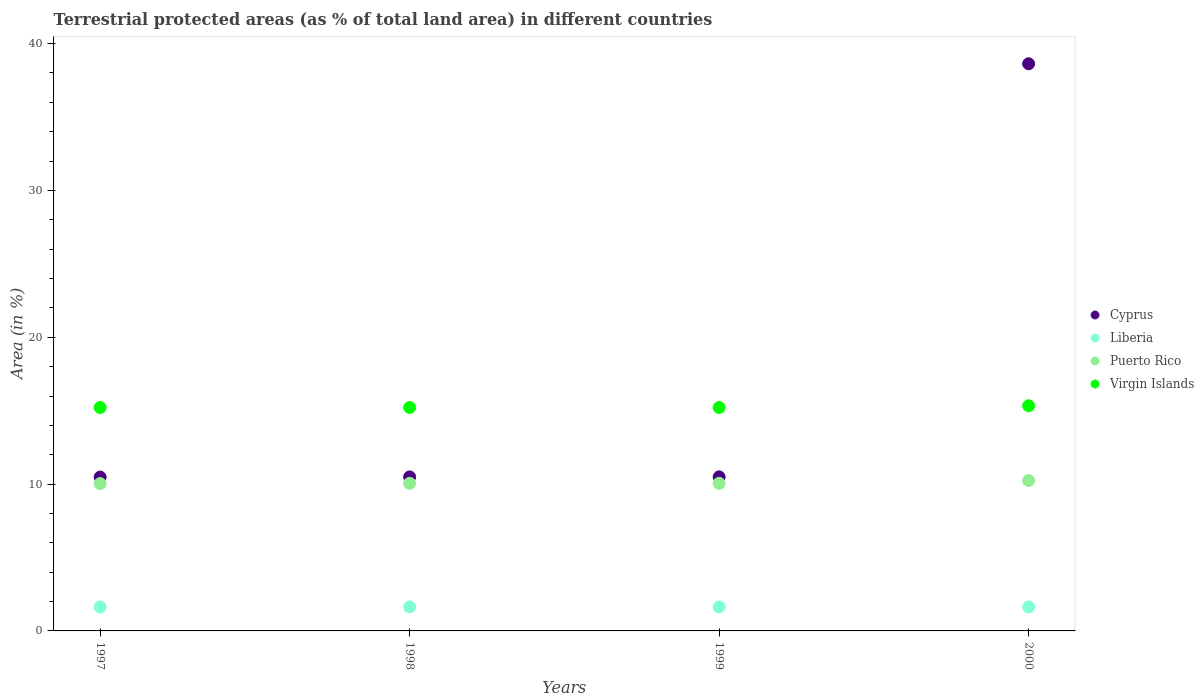What is the percentage of terrestrial protected land in Virgin Islands in 1999?
Ensure brevity in your answer.  15.22. Across all years, what is the maximum percentage of terrestrial protected land in Virgin Islands?
Make the answer very short. 15.34. Across all years, what is the minimum percentage of terrestrial protected land in Puerto Rico?
Your answer should be compact. 10.04. In which year was the percentage of terrestrial protected land in Cyprus maximum?
Keep it short and to the point. 2000. In which year was the percentage of terrestrial protected land in Cyprus minimum?
Provide a short and direct response. 1997. What is the total percentage of terrestrial protected land in Cyprus in the graph?
Provide a succinct answer. 70.09. What is the difference between the percentage of terrestrial protected land in Virgin Islands in 1998 and that in 2000?
Give a very brief answer. -0.12. What is the difference between the percentage of terrestrial protected land in Puerto Rico in 1998 and the percentage of terrestrial protected land in Virgin Islands in 1999?
Keep it short and to the point. -5.16. What is the average percentage of terrestrial protected land in Cyprus per year?
Your answer should be compact. 17.52. In the year 1998, what is the difference between the percentage of terrestrial protected land in Virgin Islands and percentage of terrestrial protected land in Puerto Rico?
Your answer should be compact. 5.16. What is the ratio of the percentage of terrestrial protected land in Virgin Islands in 1997 to that in 2000?
Ensure brevity in your answer.  0.99. What is the difference between the highest and the second highest percentage of terrestrial protected land in Cyprus?
Offer a very short reply. 28.14. What is the difference between the highest and the lowest percentage of terrestrial protected land in Cyprus?
Your answer should be very brief. 28.15. In how many years, is the percentage of terrestrial protected land in Puerto Rico greater than the average percentage of terrestrial protected land in Puerto Rico taken over all years?
Your answer should be compact. 1. Is the sum of the percentage of terrestrial protected land in Puerto Rico in 1998 and 1999 greater than the maximum percentage of terrestrial protected land in Liberia across all years?
Your response must be concise. Yes. Does the percentage of terrestrial protected land in Puerto Rico monotonically increase over the years?
Offer a terse response. No. Is the percentage of terrestrial protected land in Virgin Islands strictly less than the percentage of terrestrial protected land in Liberia over the years?
Make the answer very short. No. How many dotlines are there?
Provide a short and direct response. 4. Does the graph contain grids?
Offer a very short reply. No. How are the legend labels stacked?
Your answer should be compact. Vertical. What is the title of the graph?
Keep it short and to the point. Terrestrial protected areas (as % of total land area) in different countries. Does "Denmark" appear as one of the legend labels in the graph?
Make the answer very short. No. What is the label or title of the Y-axis?
Offer a very short reply. Area (in %). What is the Area (in %) in Cyprus in 1997?
Keep it short and to the point. 10.48. What is the Area (in %) in Liberia in 1997?
Your response must be concise. 1.63. What is the Area (in %) in Puerto Rico in 1997?
Make the answer very short. 10.04. What is the Area (in %) of Virgin Islands in 1997?
Ensure brevity in your answer.  15.22. What is the Area (in %) of Cyprus in 1998?
Ensure brevity in your answer.  10.49. What is the Area (in %) in Liberia in 1998?
Ensure brevity in your answer.  1.63. What is the Area (in %) in Puerto Rico in 1998?
Make the answer very short. 10.05. What is the Area (in %) in Virgin Islands in 1998?
Make the answer very short. 15.22. What is the Area (in %) in Cyprus in 1999?
Offer a terse response. 10.49. What is the Area (in %) of Liberia in 1999?
Your response must be concise. 1.63. What is the Area (in %) of Puerto Rico in 1999?
Make the answer very short. 10.05. What is the Area (in %) of Virgin Islands in 1999?
Give a very brief answer. 15.22. What is the Area (in %) of Cyprus in 2000?
Offer a very short reply. 38.63. What is the Area (in %) of Liberia in 2000?
Offer a terse response. 1.63. What is the Area (in %) in Puerto Rico in 2000?
Your answer should be very brief. 10.24. What is the Area (in %) of Virgin Islands in 2000?
Offer a terse response. 15.34. Across all years, what is the maximum Area (in %) in Cyprus?
Give a very brief answer. 38.63. Across all years, what is the maximum Area (in %) of Liberia?
Your answer should be compact. 1.63. Across all years, what is the maximum Area (in %) in Puerto Rico?
Make the answer very short. 10.24. Across all years, what is the maximum Area (in %) of Virgin Islands?
Your response must be concise. 15.34. Across all years, what is the minimum Area (in %) of Cyprus?
Make the answer very short. 10.48. Across all years, what is the minimum Area (in %) of Liberia?
Make the answer very short. 1.63. Across all years, what is the minimum Area (in %) of Puerto Rico?
Provide a succinct answer. 10.04. Across all years, what is the minimum Area (in %) of Virgin Islands?
Your answer should be compact. 15.22. What is the total Area (in %) of Cyprus in the graph?
Make the answer very short. 70.09. What is the total Area (in %) of Liberia in the graph?
Ensure brevity in your answer.  6.53. What is the total Area (in %) in Puerto Rico in the graph?
Give a very brief answer. 40.39. What is the total Area (in %) in Virgin Islands in the graph?
Ensure brevity in your answer.  60.99. What is the difference between the Area (in %) of Cyprus in 1997 and that in 1998?
Your response must be concise. -0.01. What is the difference between the Area (in %) in Liberia in 1997 and that in 1998?
Your response must be concise. 0. What is the difference between the Area (in %) of Puerto Rico in 1997 and that in 1998?
Keep it short and to the point. -0.02. What is the difference between the Area (in %) of Cyprus in 1997 and that in 1999?
Provide a succinct answer. -0.01. What is the difference between the Area (in %) in Liberia in 1997 and that in 1999?
Your answer should be very brief. 0. What is the difference between the Area (in %) of Puerto Rico in 1997 and that in 1999?
Give a very brief answer. -0.02. What is the difference between the Area (in %) in Virgin Islands in 1997 and that in 1999?
Offer a terse response. 0. What is the difference between the Area (in %) of Cyprus in 1997 and that in 2000?
Offer a very short reply. -28.15. What is the difference between the Area (in %) in Liberia in 1997 and that in 2000?
Offer a very short reply. 0. What is the difference between the Area (in %) in Puerto Rico in 1997 and that in 2000?
Ensure brevity in your answer.  -0.2. What is the difference between the Area (in %) in Virgin Islands in 1997 and that in 2000?
Your response must be concise. -0.12. What is the difference between the Area (in %) of Cyprus in 1998 and that in 1999?
Provide a short and direct response. -0. What is the difference between the Area (in %) of Puerto Rico in 1998 and that in 1999?
Your answer should be very brief. 0. What is the difference between the Area (in %) of Virgin Islands in 1998 and that in 1999?
Offer a terse response. 0. What is the difference between the Area (in %) in Cyprus in 1998 and that in 2000?
Offer a very short reply. -28.14. What is the difference between the Area (in %) in Liberia in 1998 and that in 2000?
Offer a very short reply. 0. What is the difference between the Area (in %) in Puerto Rico in 1998 and that in 2000?
Offer a very short reply. -0.18. What is the difference between the Area (in %) of Virgin Islands in 1998 and that in 2000?
Your answer should be very brief. -0.12. What is the difference between the Area (in %) of Cyprus in 1999 and that in 2000?
Your response must be concise. -28.14. What is the difference between the Area (in %) of Liberia in 1999 and that in 2000?
Your answer should be compact. 0. What is the difference between the Area (in %) in Puerto Rico in 1999 and that in 2000?
Offer a terse response. -0.18. What is the difference between the Area (in %) in Virgin Islands in 1999 and that in 2000?
Your answer should be very brief. -0.12. What is the difference between the Area (in %) of Cyprus in 1997 and the Area (in %) of Liberia in 1998?
Give a very brief answer. 8.85. What is the difference between the Area (in %) in Cyprus in 1997 and the Area (in %) in Puerto Rico in 1998?
Ensure brevity in your answer.  0.42. What is the difference between the Area (in %) of Cyprus in 1997 and the Area (in %) of Virgin Islands in 1998?
Your answer should be very brief. -4.74. What is the difference between the Area (in %) in Liberia in 1997 and the Area (in %) in Puerto Rico in 1998?
Make the answer very short. -8.42. What is the difference between the Area (in %) of Liberia in 1997 and the Area (in %) of Virgin Islands in 1998?
Make the answer very short. -13.59. What is the difference between the Area (in %) of Puerto Rico in 1997 and the Area (in %) of Virgin Islands in 1998?
Offer a terse response. -5.18. What is the difference between the Area (in %) of Cyprus in 1997 and the Area (in %) of Liberia in 1999?
Offer a very short reply. 8.85. What is the difference between the Area (in %) of Cyprus in 1997 and the Area (in %) of Puerto Rico in 1999?
Ensure brevity in your answer.  0.42. What is the difference between the Area (in %) in Cyprus in 1997 and the Area (in %) in Virgin Islands in 1999?
Your response must be concise. -4.74. What is the difference between the Area (in %) of Liberia in 1997 and the Area (in %) of Puerto Rico in 1999?
Provide a short and direct response. -8.42. What is the difference between the Area (in %) in Liberia in 1997 and the Area (in %) in Virgin Islands in 1999?
Your response must be concise. -13.59. What is the difference between the Area (in %) of Puerto Rico in 1997 and the Area (in %) of Virgin Islands in 1999?
Offer a very short reply. -5.18. What is the difference between the Area (in %) in Cyprus in 1997 and the Area (in %) in Liberia in 2000?
Provide a short and direct response. 8.85. What is the difference between the Area (in %) of Cyprus in 1997 and the Area (in %) of Puerto Rico in 2000?
Keep it short and to the point. 0.24. What is the difference between the Area (in %) in Cyprus in 1997 and the Area (in %) in Virgin Islands in 2000?
Keep it short and to the point. -4.86. What is the difference between the Area (in %) in Liberia in 1997 and the Area (in %) in Puerto Rico in 2000?
Keep it short and to the point. -8.61. What is the difference between the Area (in %) of Liberia in 1997 and the Area (in %) of Virgin Islands in 2000?
Your answer should be very brief. -13.7. What is the difference between the Area (in %) of Puerto Rico in 1997 and the Area (in %) of Virgin Islands in 2000?
Give a very brief answer. -5.3. What is the difference between the Area (in %) in Cyprus in 1998 and the Area (in %) in Liberia in 1999?
Provide a succinct answer. 8.86. What is the difference between the Area (in %) in Cyprus in 1998 and the Area (in %) in Puerto Rico in 1999?
Your answer should be compact. 0.43. What is the difference between the Area (in %) in Cyprus in 1998 and the Area (in %) in Virgin Islands in 1999?
Offer a terse response. -4.73. What is the difference between the Area (in %) of Liberia in 1998 and the Area (in %) of Puerto Rico in 1999?
Your answer should be compact. -8.42. What is the difference between the Area (in %) of Liberia in 1998 and the Area (in %) of Virgin Islands in 1999?
Keep it short and to the point. -13.59. What is the difference between the Area (in %) of Puerto Rico in 1998 and the Area (in %) of Virgin Islands in 1999?
Provide a short and direct response. -5.16. What is the difference between the Area (in %) in Cyprus in 1998 and the Area (in %) in Liberia in 2000?
Offer a very short reply. 8.86. What is the difference between the Area (in %) of Cyprus in 1998 and the Area (in %) of Puerto Rico in 2000?
Provide a short and direct response. 0.25. What is the difference between the Area (in %) of Cyprus in 1998 and the Area (in %) of Virgin Islands in 2000?
Ensure brevity in your answer.  -4.85. What is the difference between the Area (in %) of Liberia in 1998 and the Area (in %) of Puerto Rico in 2000?
Give a very brief answer. -8.61. What is the difference between the Area (in %) in Liberia in 1998 and the Area (in %) in Virgin Islands in 2000?
Give a very brief answer. -13.7. What is the difference between the Area (in %) of Puerto Rico in 1998 and the Area (in %) of Virgin Islands in 2000?
Your answer should be compact. -5.28. What is the difference between the Area (in %) of Cyprus in 1999 and the Area (in %) of Liberia in 2000?
Offer a terse response. 8.86. What is the difference between the Area (in %) of Cyprus in 1999 and the Area (in %) of Puerto Rico in 2000?
Provide a succinct answer. 0.25. What is the difference between the Area (in %) of Cyprus in 1999 and the Area (in %) of Virgin Islands in 2000?
Your response must be concise. -4.84. What is the difference between the Area (in %) of Liberia in 1999 and the Area (in %) of Puerto Rico in 2000?
Your response must be concise. -8.61. What is the difference between the Area (in %) in Liberia in 1999 and the Area (in %) in Virgin Islands in 2000?
Make the answer very short. -13.7. What is the difference between the Area (in %) of Puerto Rico in 1999 and the Area (in %) of Virgin Islands in 2000?
Keep it short and to the point. -5.28. What is the average Area (in %) of Cyprus per year?
Offer a terse response. 17.52. What is the average Area (in %) of Liberia per year?
Ensure brevity in your answer.  1.63. What is the average Area (in %) in Puerto Rico per year?
Offer a very short reply. 10.1. What is the average Area (in %) in Virgin Islands per year?
Provide a short and direct response. 15.25. In the year 1997, what is the difference between the Area (in %) in Cyprus and Area (in %) in Liberia?
Offer a very short reply. 8.85. In the year 1997, what is the difference between the Area (in %) of Cyprus and Area (in %) of Puerto Rico?
Ensure brevity in your answer.  0.44. In the year 1997, what is the difference between the Area (in %) in Cyprus and Area (in %) in Virgin Islands?
Provide a succinct answer. -4.74. In the year 1997, what is the difference between the Area (in %) of Liberia and Area (in %) of Puerto Rico?
Provide a succinct answer. -8.4. In the year 1997, what is the difference between the Area (in %) of Liberia and Area (in %) of Virgin Islands?
Your answer should be compact. -13.59. In the year 1997, what is the difference between the Area (in %) of Puerto Rico and Area (in %) of Virgin Islands?
Offer a terse response. -5.18. In the year 1998, what is the difference between the Area (in %) in Cyprus and Area (in %) in Liberia?
Your answer should be compact. 8.86. In the year 1998, what is the difference between the Area (in %) in Cyprus and Area (in %) in Puerto Rico?
Your response must be concise. 0.43. In the year 1998, what is the difference between the Area (in %) in Cyprus and Area (in %) in Virgin Islands?
Your response must be concise. -4.73. In the year 1998, what is the difference between the Area (in %) in Liberia and Area (in %) in Puerto Rico?
Give a very brief answer. -8.42. In the year 1998, what is the difference between the Area (in %) of Liberia and Area (in %) of Virgin Islands?
Ensure brevity in your answer.  -13.59. In the year 1998, what is the difference between the Area (in %) of Puerto Rico and Area (in %) of Virgin Islands?
Keep it short and to the point. -5.16. In the year 1999, what is the difference between the Area (in %) of Cyprus and Area (in %) of Liberia?
Your response must be concise. 8.86. In the year 1999, what is the difference between the Area (in %) of Cyprus and Area (in %) of Puerto Rico?
Keep it short and to the point. 0.44. In the year 1999, what is the difference between the Area (in %) in Cyprus and Area (in %) in Virgin Islands?
Provide a succinct answer. -4.73. In the year 1999, what is the difference between the Area (in %) in Liberia and Area (in %) in Puerto Rico?
Give a very brief answer. -8.42. In the year 1999, what is the difference between the Area (in %) of Liberia and Area (in %) of Virgin Islands?
Offer a very short reply. -13.59. In the year 1999, what is the difference between the Area (in %) in Puerto Rico and Area (in %) in Virgin Islands?
Provide a short and direct response. -5.16. In the year 2000, what is the difference between the Area (in %) of Cyprus and Area (in %) of Liberia?
Your answer should be very brief. 37. In the year 2000, what is the difference between the Area (in %) in Cyprus and Area (in %) in Puerto Rico?
Offer a very short reply. 28.39. In the year 2000, what is the difference between the Area (in %) in Cyprus and Area (in %) in Virgin Islands?
Ensure brevity in your answer.  23.29. In the year 2000, what is the difference between the Area (in %) of Liberia and Area (in %) of Puerto Rico?
Offer a very short reply. -8.61. In the year 2000, what is the difference between the Area (in %) in Liberia and Area (in %) in Virgin Islands?
Offer a terse response. -13.71. In the year 2000, what is the difference between the Area (in %) of Puerto Rico and Area (in %) of Virgin Islands?
Ensure brevity in your answer.  -5.1. What is the ratio of the Area (in %) of Cyprus in 1997 to that in 1998?
Your answer should be compact. 1. What is the ratio of the Area (in %) of Puerto Rico in 1997 to that in 1998?
Your answer should be compact. 1. What is the ratio of the Area (in %) in Cyprus in 1997 to that in 1999?
Offer a very short reply. 1. What is the ratio of the Area (in %) in Puerto Rico in 1997 to that in 1999?
Keep it short and to the point. 1. What is the ratio of the Area (in %) in Virgin Islands in 1997 to that in 1999?
Keep it short and to the point. 1. What is the ratio of the Area (in %) in Cyprus in 1997 to that in 2000?
Give a very brief answer. 0.27. What is the ratio of the Area (in %) of Liberia in 1997 to that in 2000?
Your response must be concise. 1. What is the ratio of the Area (in %) in Puerto Rico in 1997 to that in 2000?
Offer a very short reply. 0.98. What is the ratio of the Area (in %) of Virgin Islands in 1997 to that in 2000?
Your answer should be very brief. 0.99. What is the ratio of the Area (in %) of Liberia in 1998 to that in 1999?
Offer a terse response. 1. What is the ratio of the Area (in %) in Puerto Rico in 1998 to that in 1999?
Give a very brief answer. 1. What is the ratio of the Area (in %) of Virgin Islands in 1998 to that in 1999?
Give a very brief answer. 1. What is the ratio of the Area (in %) of Cyprus in 1998 to that in 2000?
Your answer should be very brief. 0.27. What is the ratio of the Area (in %) of Liberia in 1998 to that in 2000?
Ensure brevity in your answer.  1. What is the ratio of the Area (in %) in Virgin Islands in 1998 to that in 2000?
Keep it short and to the point. 0.99. What is the ratio of the Area (in %) in Cyprus in 1999 to that in 2000?
Your response must be concise. 0.27. What is the ratio of the Area (in %) in Puerto Rico in 1999 to that in 2000?
Your answer should be compact. 0.98. What is the ratio of the Area (in %) of Virgin Islands in 1999 to that in 2000?
Provide a short and direct response. 0.99. What is the difference between the highest and the second highest Area (in %) of Cyprus?
Your answer should be very brief. 28.14. What is the difference between the highest and the second highest Area (in %) of Liberia?
Give a very brief answer. 0. What is the difference between the highest and the second highest Area (in %) in Puerto Rico?
Give a very brief answer. 0.18. What is the difference between the highest and the second highest Area (in %) in Virgin Islands?
Provide a succinct answer. 0.12. What is the difference between the highest and the lowest Area (in %) in Cyprus?
Offer a very short reply. 28.15. What is the difference between the highest and the lowest Area (in %) in Liberia?
Offer a very short reply. 0. What is the difference between the highest and the lowest Area (in %) of Puerto Rico?
Give a very brief answer. 0.2. What is the difference between the highest and the lowest Area (in %) of Virgin Islands?
Give a very brief answer. 0.12. 